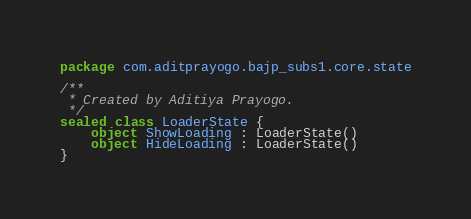<code> <loc_0><loc_0><loc_500><loc_500><_Kotlin_>package com.aditprayogo.bajp_subs1.core.state

/**
 * Created by Aditiya Prayogo.
 */
sealed class LoaderState {
    object ShowLoading : LoaderState()
    object HideLoading : LoaderState()
}</code> 